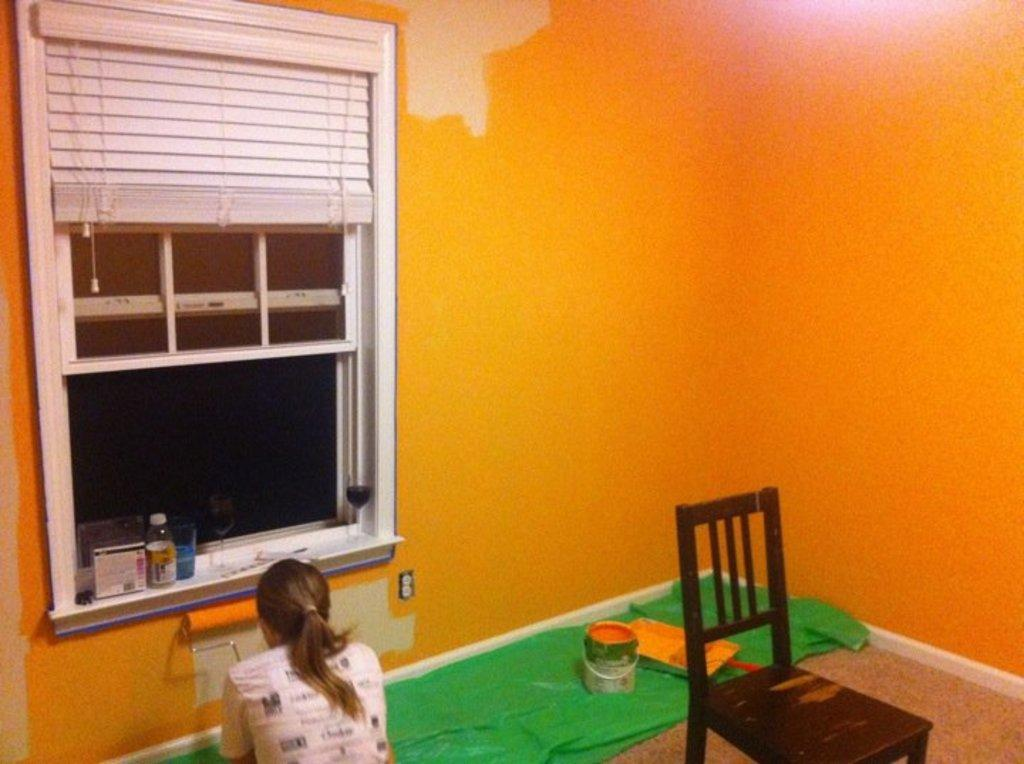What piece of furniture can be found in the room? There is a chair in the room. What is on the floor in the room? There is a green color cloth on the floor. What is the woman in the room doing? The woman is painting the wall. What color is the wall being painted? The wall being painted is of orange color. Is there any source of natural light in the room? Yes, there is a window beside the wall. What time of day is it in the image? The time of day cannot be determined from the image, as there are no clues about the time. What color are the woman's eyes in the image? There is no information about the woman's eyes in the image, so we cannot determine their color. 